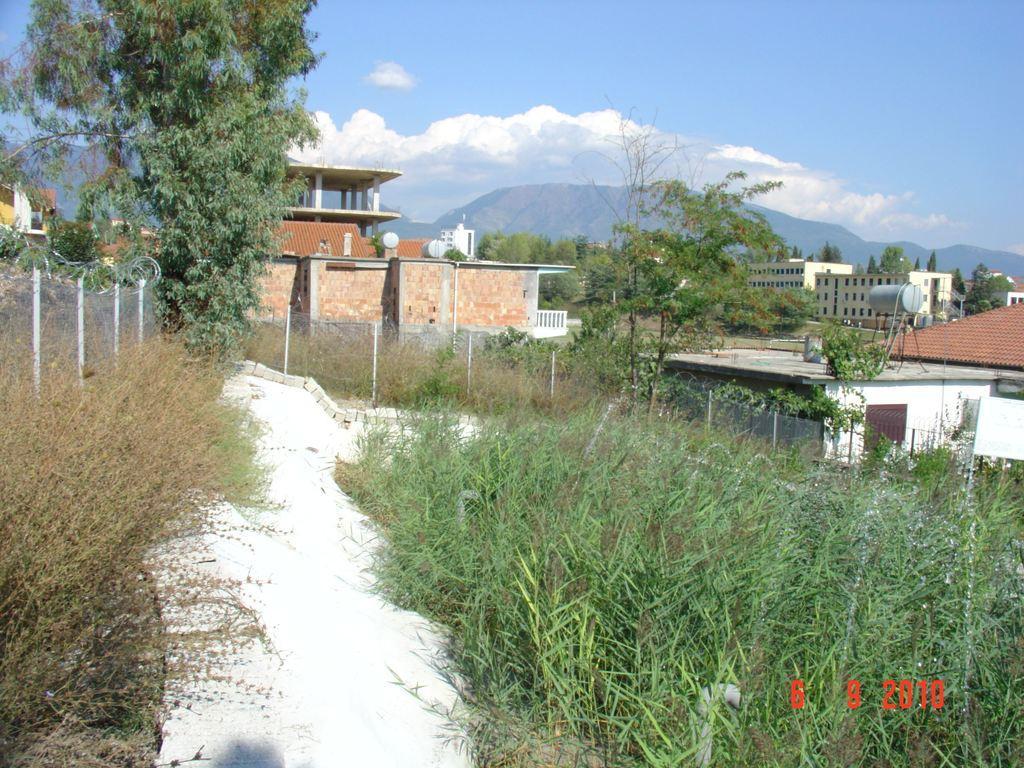Could you give a brief overview of what you see in this image? At the bottom of the image there are plants. There is a fencing. In the background of the image there are buildings. There are mountains, trees. At the top of the image there is sky and clouds. 